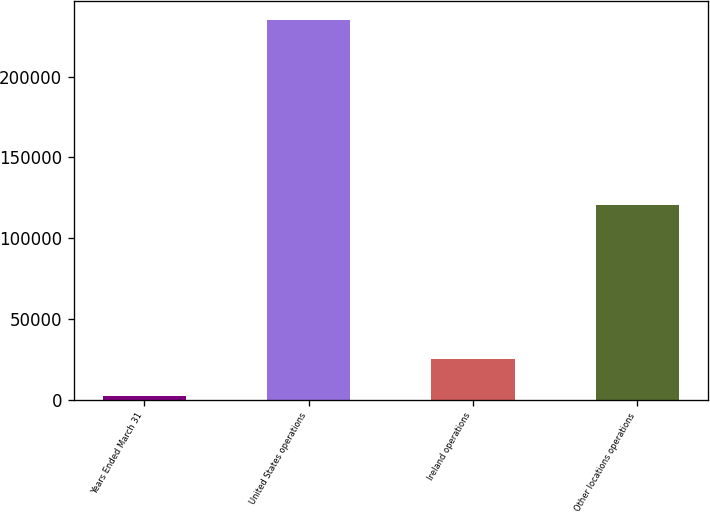<chart> <loc_0><loc_0><loc_500><loc_500><bar_chart><fcel>Years Ended March 31<fcel>United States operations<fcel>Ireland operations<fcel>Other locations operations<nl><fcel>2019<fcel>235405<fcel>25357.6<fcel>120372<nl></chart> 